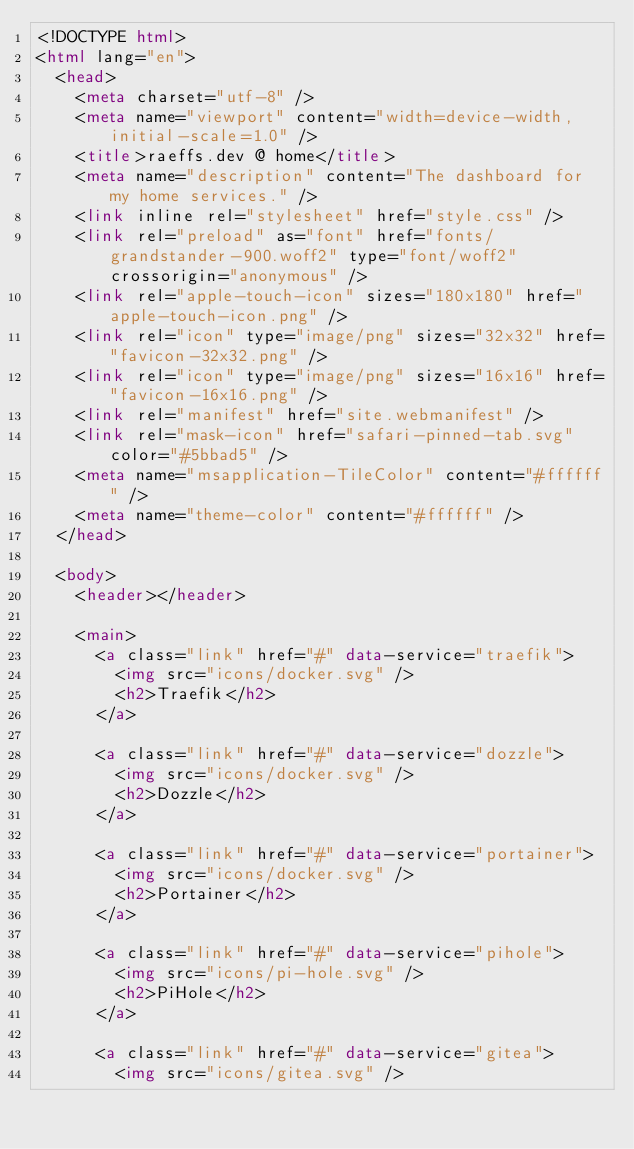Convert code to text. <code><loc_0><loc_0><loc_500><loc_500><_HTML_><!DOCTYPE html>
<html lang="en">
  <head>
    <meta charset="utf-8" />
    <meta name="viewport" content="width=device-width, initial-scale=1.0" />
    <title>raeffs.dev @ home</title>
    <meta name="description" content="The dashboard for my home services." />
    <link inline rel="stylesheet" href="style.css" />
    <link rel="preload" as="font" href="fonts/grandstander-900.woff2" type="font/woff2" crossorigin="anonymous" />
    <link rel="apple-touch-icon" sizes="180x180" href="apple-touch-icon.png" />
    <link rel="icon" type="image/png" sizes="32x32" href="favicon-32x32.png" />
    <link rel="icon" type="image/png" sizes="16x16" href="favicon-16x16.png" />
    <link rel="manifest" href="site.webmanifest" />
    <link rel="mask-icon" href="safari-pinned-tab.svg" color="#5bbad5" />
    <meta name="msapplication-TileColor" content="#ffffff" />
    <meta name="theme-color" content="#ffffff" />
  </head>

  <body>
    <header></header>

    <main>
      <a class="link" href="#" data-service="traefik">
        <img src="icons/docker.svg" />
        <h2>Traefik</h2>
      </a>

      <a class="link" href="#" data-service="dozzle">
        <img src="icons/docker.svg" />
        <h2>Dozzle</h2>
      </a>

      <a class="link" href="#" data-service="portainer">
        <img src="icons/docker.svg" />
        <h2>Portainer</h2>
      </a>

      <a class="link" href="#" data-service="pihole">
        <img src="icons/pi-hole.svg" />
        <h2>PiHole</h2>
      </a>

      <a class="link" href="#" data-service="gitea">
        <img src="icons/gitea.svg" /></code> 